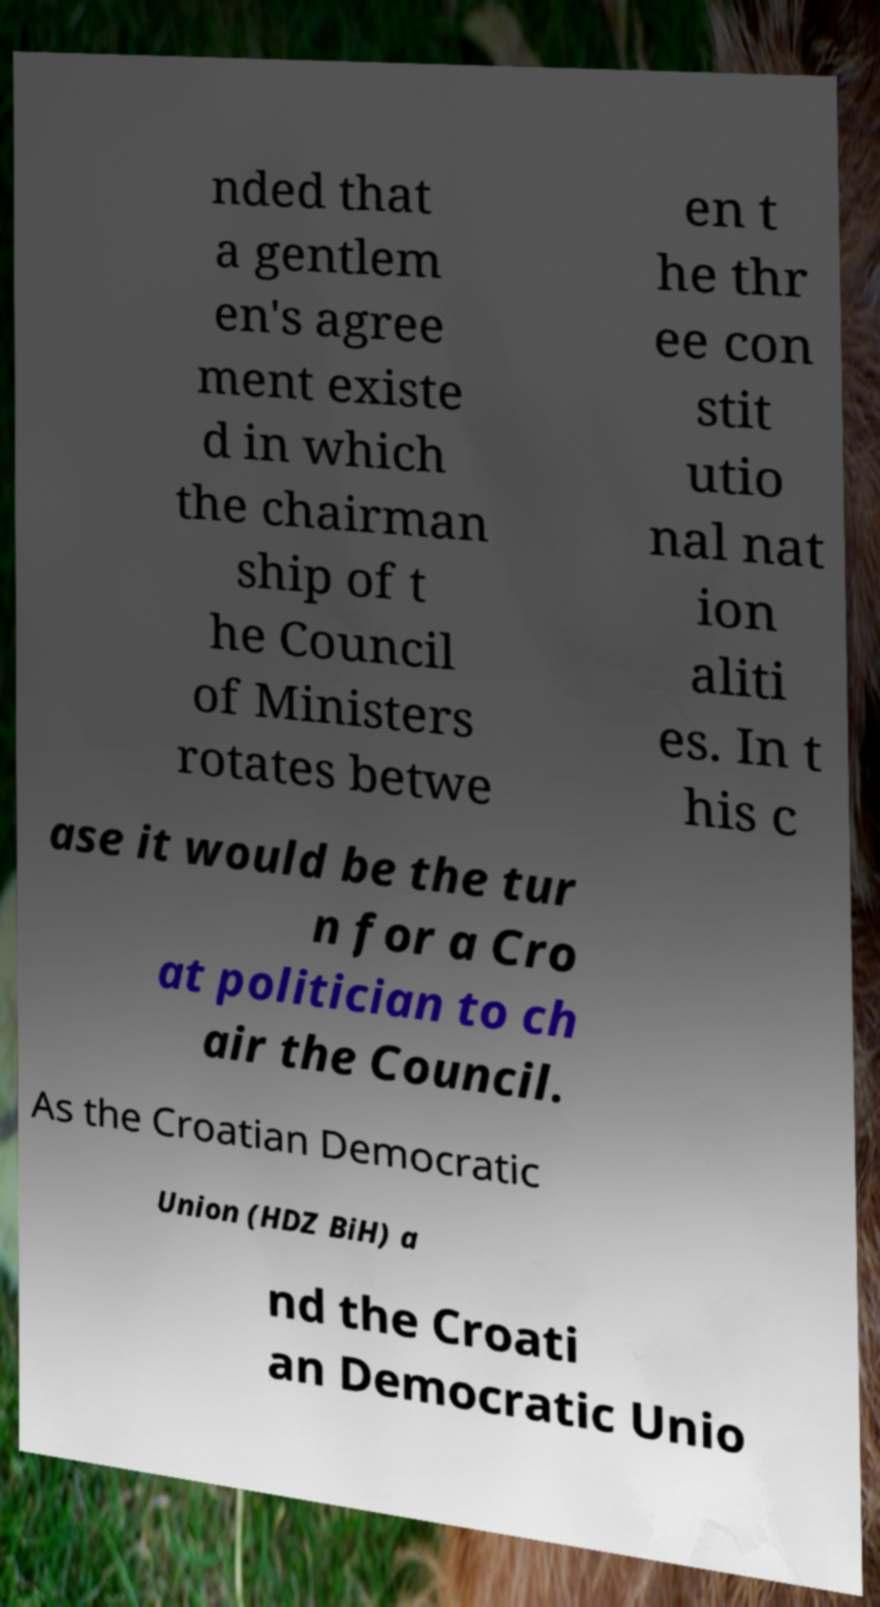For documentation purposes, I need the text within this image transcribed. Could you provide that? nded that a gentlem en's agree ment existe d in which the chairman ship of t he Council of Ministers rotates betwe en t he thr ee con stit utio nal nat ion aliti es. In t his c ase it would be the tur n for a Cro at politician to ch air the Council. As the Croatian Democratic Union (HDZ BiH) a nd the Croati an Democratic Unio 